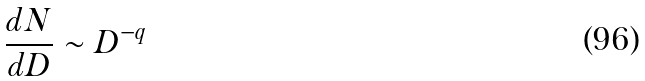<formula> <loc_0><loc_0><loc_500><loc_500>\frac { d N } { d D } \sim D ^ { - q }</formula> 